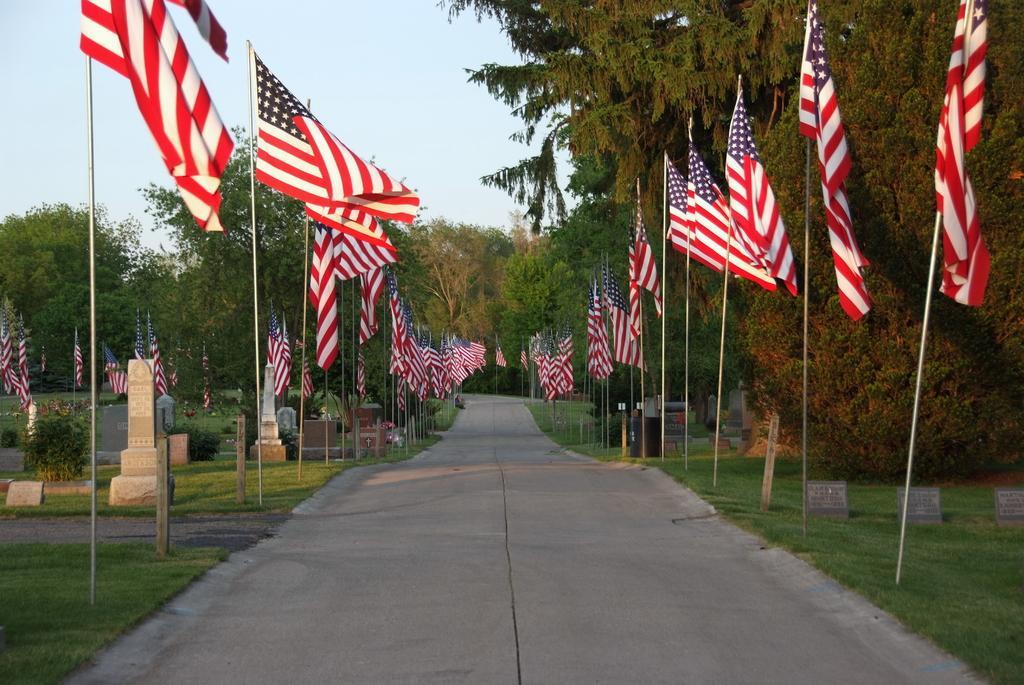How would you summarize this image in a sentence or two? In this image in the middle there is a path. On the both sides there are many flags. Here there are pillars. In the background there are trees. 